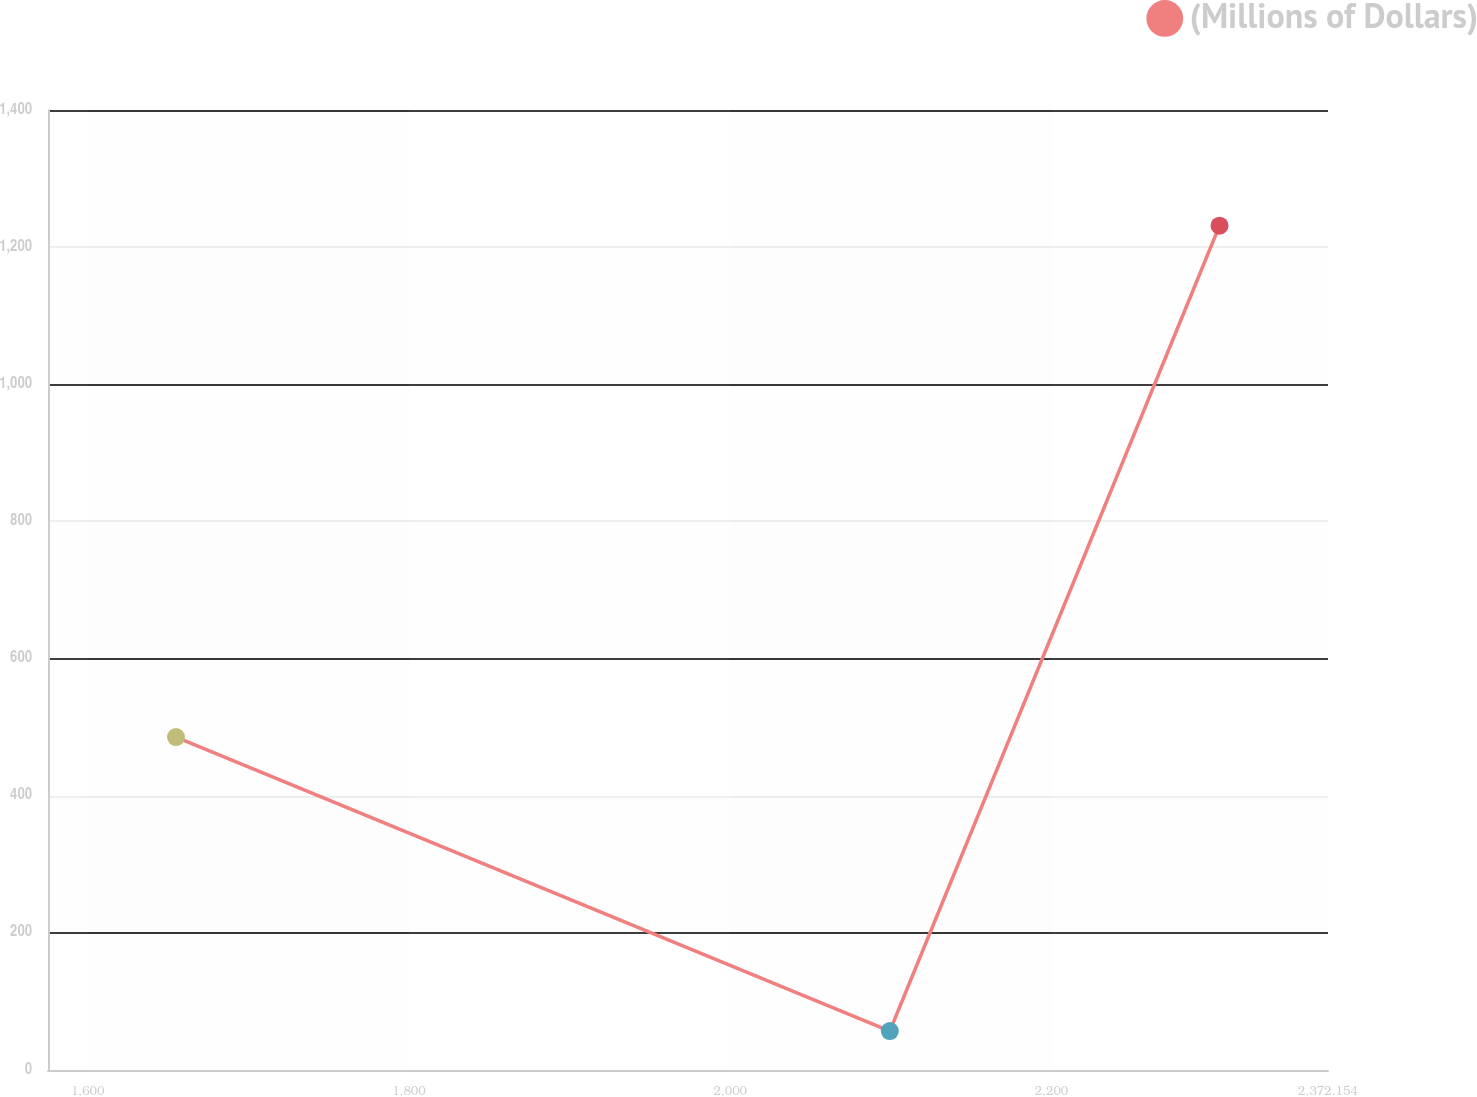Convert chart. <chart><loc_0><loc_0><loc_500><loc_500><line_chart><ecel><fcel>(Millions of Dollars)<nl><fcel>1654.98<fcel>485.47<nl><fcel>2099.35<fcel>56.78<nl><fcel>2304.62<fcel>1231.29<nl><fcel>2378.23<fcel>250.57<nl><fcel>2451.84<fcel>368.02<nl></chart> 